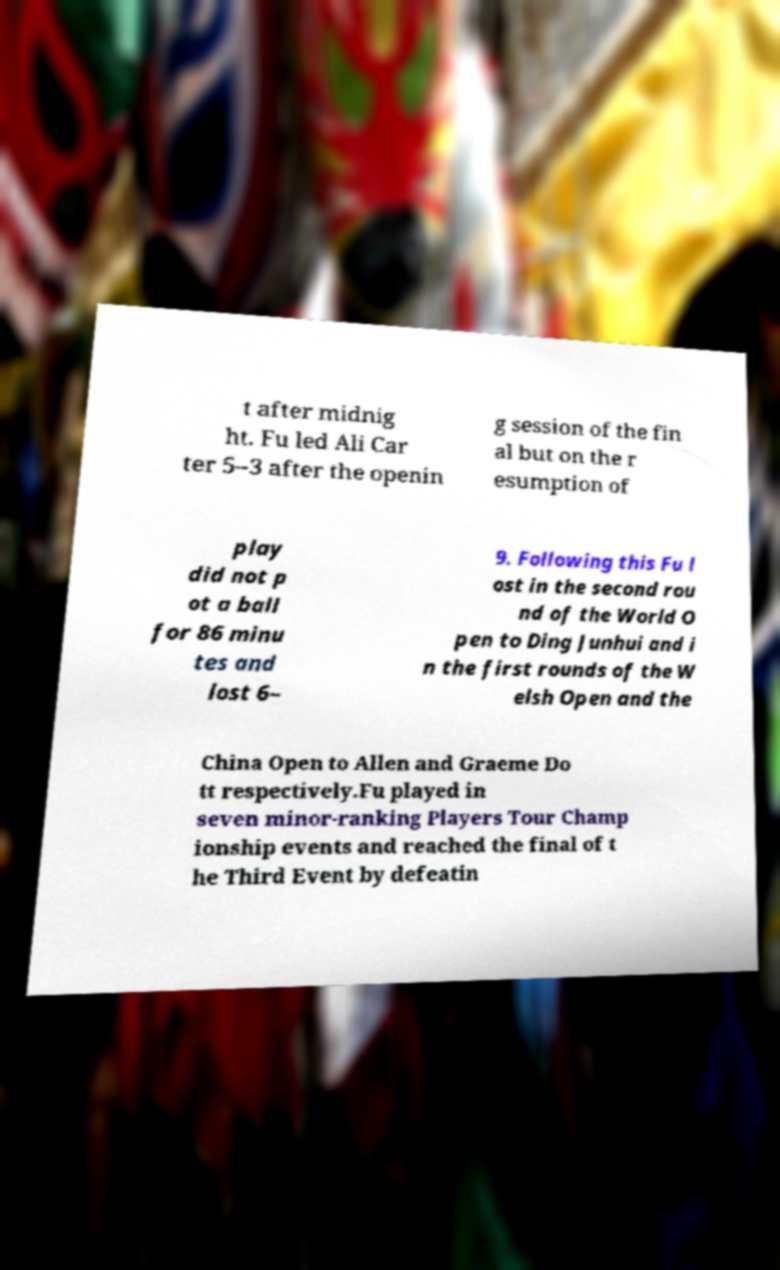Please read and relay the text visible in this image. What does it say? t after midnig ht. Fu led Ali Car ter 5–3 after the openin g session of the fin al but on the r esumption of play did not p ot a ball for 86 minu tes and lost 6– 9. Following this Fu l ost in the second rou nd of the World O pen to Ding Junhui and i n the first rounds of the W elsh Open and the China Open to Allen and Graeme Do tt respectively.Fu played in seven minor-ranking Players Tour Champ ionship events and reached the final of t he Third Event by defeatin 